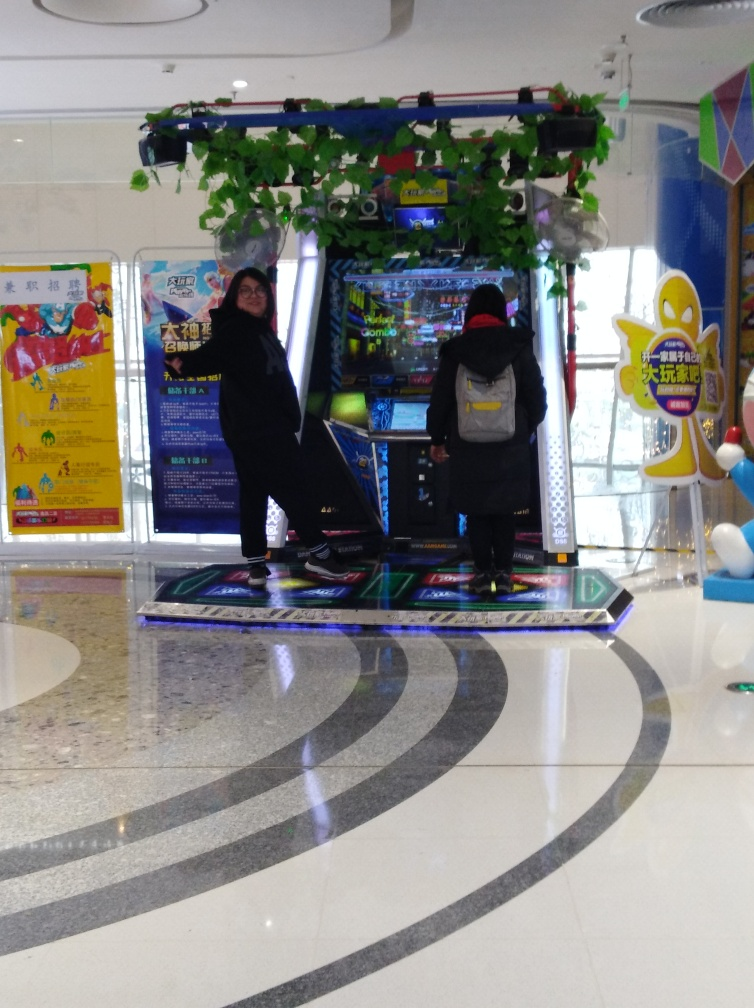Can you tell me about the arcade environment? Certainly, the arcade setting looks lively and colorful, with vibrant posters and signs promoting games and events. A faux vine with flowers is hanging overhead, adding a playful decoration to the space. The glossy tiled floor reflects the arcade's lights, contributing to the energetic ambiance. 